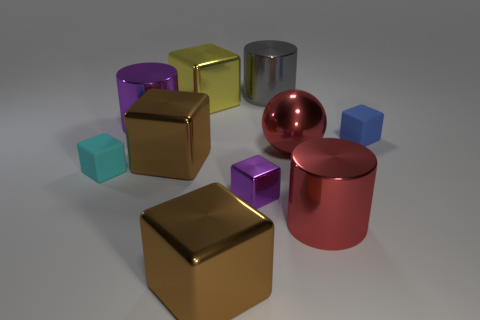Does the big metal thing that is to the right of the large red ball have the same color as the metal ball?
Your response must be concise. Yes. There is a red object behind the purple metallic cube; does it have the same size as the brown metallic cube in front of the tiny purple thing?
Your answer should be very brief. Yes. There is a gray object that is made of the same material as the large ball; what is its size?
Provide a short and direct response. Large. How many objects are both to the right of the tiny cyan block and in front of the gray cylinder?
Give a very brief answer. 8. How many objects are either cyan balls or tiny rubber things to the left of the big gray metal thing?
Ensure brevity in your answer.  1. The big shiny object that is the same color as the tiny metallic block is what shape?
Your answer should be compact. Cylinder. There is a cylinder that is in front of the cyan matte block; what is its color?
Provide a short and direct response. Red. What number of things are either metallic objects that are on the right side of the tiny metal block or large yellow metal cubes?
Offer a very short reply. 4. There is a metallic sphere that is the same size as the red metallic cylinder; what is its color?
Offer a terse response. Red. Is the number of big purple shiny objects that are on the right side of the tiny purple shiny block greater than the number of large gray metallic objects?
Offer a very short reply. No. 